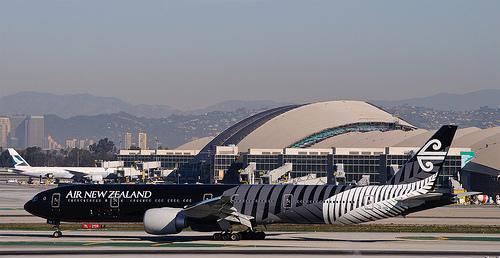How many planes are there?
Give a very brief answer. 2. 